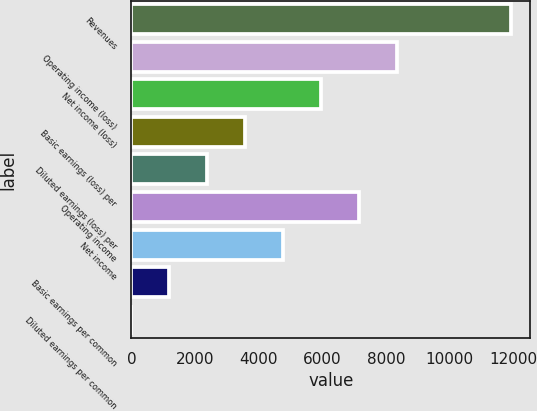<chart> <loc_0><loc_0><loc_500><loc_500><bar_chart><fcel>Revenues<fcel>Operating income (loss)<fcel>Net income (loss)<fcel>Basic earnings (loss) per<fcel>Diluted earnings (loss) per<fcel>Operating income<fcel>Net income<fcel>Basic earnings per common<fcel>Diluted earnings per common<nl><fcel>11939<fcel>8357.83<fcel>5970.38<fcel>3582.93<fcel>2389.2<fcel>7164.11<fcel>4776.65<fcel>1195.48<fcel>1.75<nl></chart> 